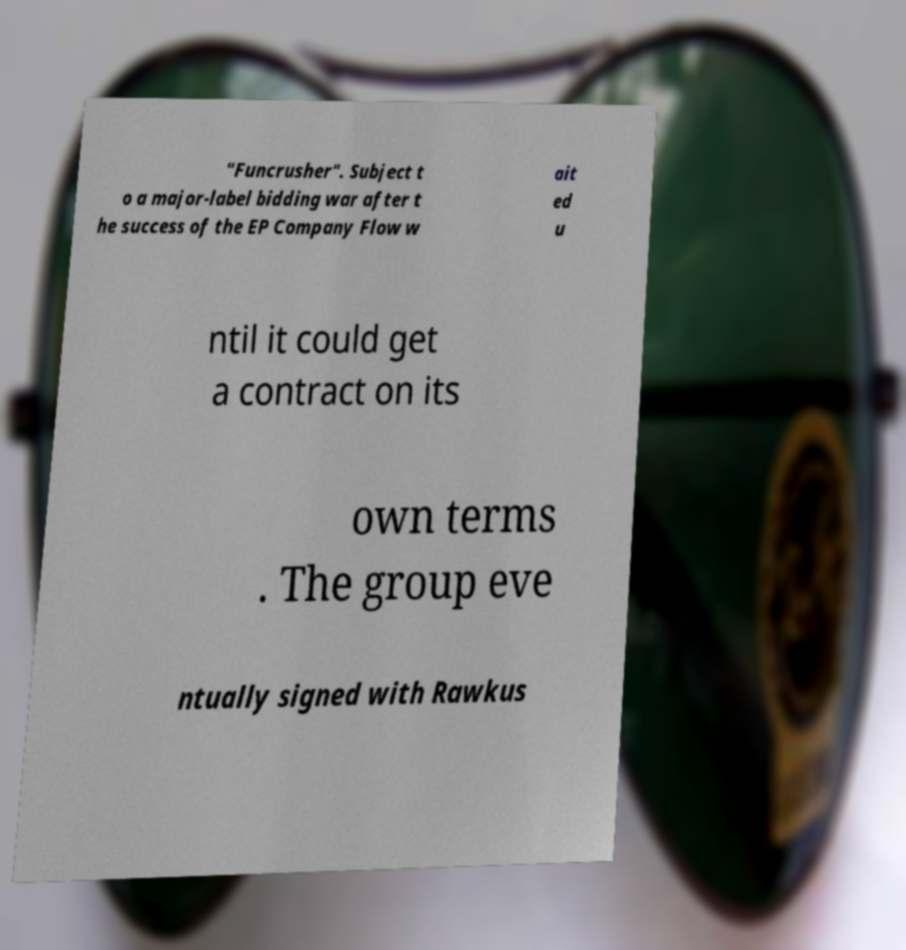I need the written content from this picture converted into text. Can you do that? "Funcrusher". Subject t o a major-label bidding war after t he success of the EP Company Flow w ait ed u ntil it could get a contract on its own terms . The group eve ntually signed with Rawkus 